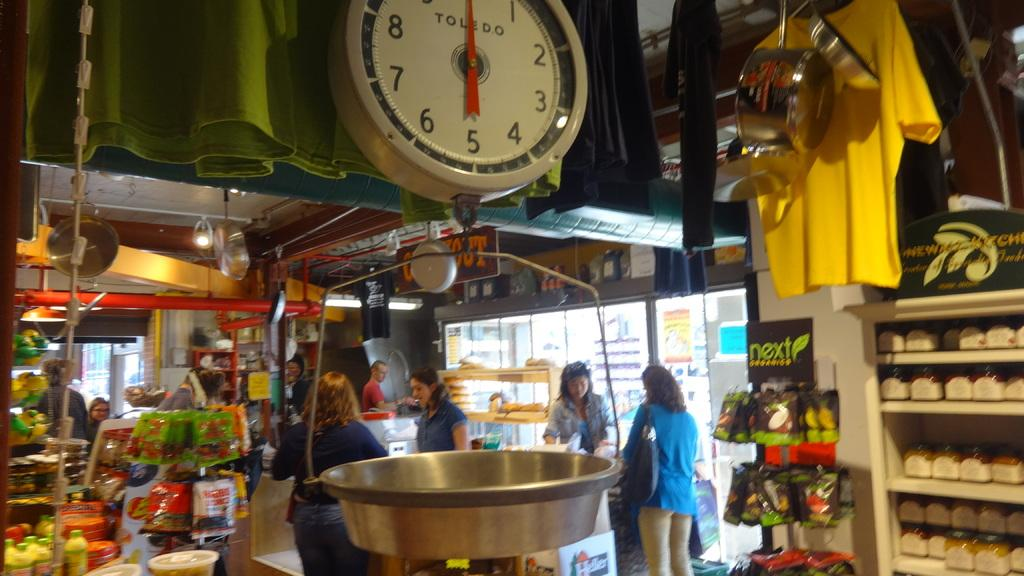<image>
Share a concise interpretation of the image provided. A clock hangs above a market that reads TOLEDO. 